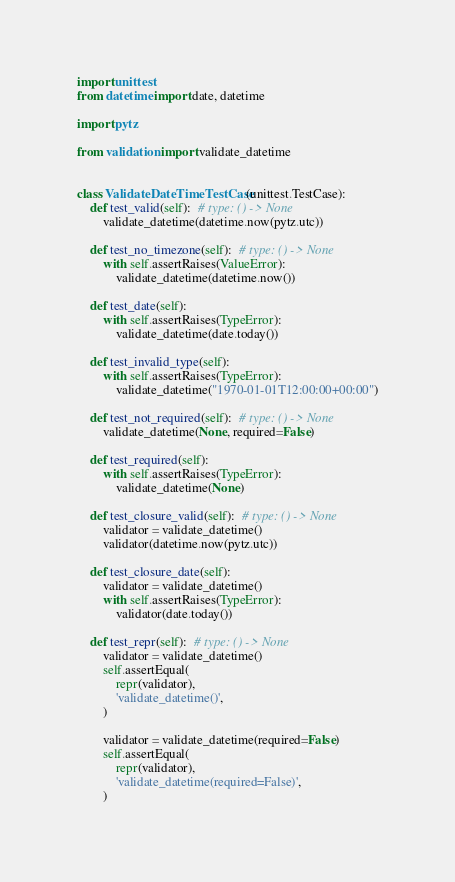<code> <loc_0><loc_0><loc_500><loc_500><_Python_>import unittest
from datetime import date, datetime

import pytz

from validation import validate_datetime


class ValidateDateTimeTestCase(unittest.TestCase):
    def test_valid(self):  # type: () -> None
        validate_datetime(datetime.now(pytz.utc))

    def test_no_timezone(self):  # type: () -> None
        with self.assertRaises(ValueError):
            validate_datetime(datetime.now())

    def test_date(self):
        with self.assertRaises(TypeError):
            validate_datetime(date.today())

    def test_invalid_type(self):
        with self.assertRaises(TypeError):
            validate_datetime("1970-01-01T12:00:00+00:00")

    def test_not_required(self):  # type: () -> None
        validate_datetime(None, required=False)

    def test_required(self):
        with self.assertRaises(TypeError):
            validate_datetime(None)

    def test_closure_valid(self):  # type: () -> None
        validator = validate_datetime()
        validator(datetime.now(pytz.utc))

    def test_closure_date(self):
        validator = validate_datetime()
        with self.assertRaises(TypeError):
            validator(date.today())

    def test_repr(self):  # type: () -> None
        validator = validate_datetime()
        self.assertEqual(
            repr(validator),
            'validate_datetime()',
        )

        validator = validate_datetime(required=False)
        self.assertEqual(
            repr(validator),
            'validate_datetime(required=False)',
        )
</code> 